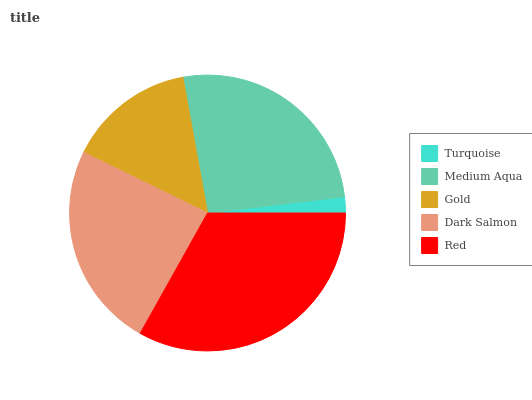Is Turquoise the minimum?
Answer yes or no. Yes. Is Red the maximum?
Answer yes or no. Yes. Is Medium Aqua the minimum?
Answer yes or no. No. Is Medium Aqua the maximum?
Answer yes or no. No. Is Medium Aqua greater than Turquoise?
Answer yes or no. Yes. Is Turquoise less than Medium Aqua?
Answer yes or no. Yes. Is Turquoise greater than Medium Aqua?
Answer yes or no. No. Is Medium Aqua less than Turquoise?
Answer yes or no. No. Is Dark Salmon the high median?
Answer yes or no. Yes. Is Dark Salmon the low median?
Answer yes or no. Yes. Is Gold the high median?
Answer yes or no. No. Is Turquoise the low median?
Answer yes or no. No. 